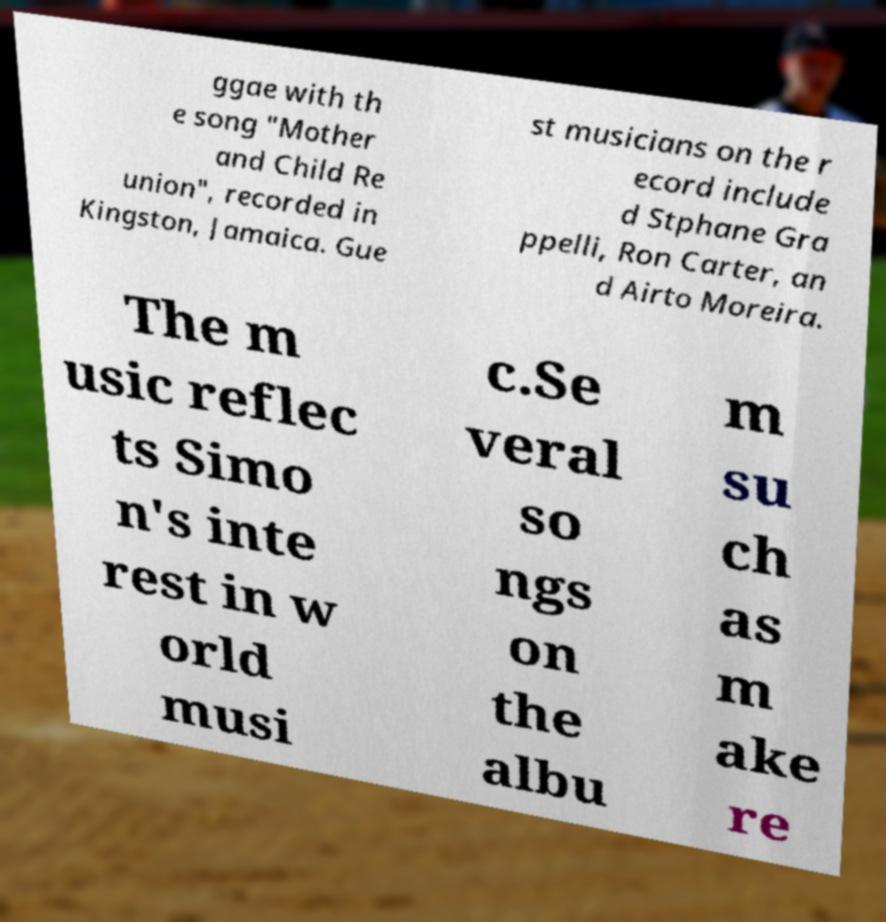Please identify and transcribe the text found in this image. ggae with th e song "Mother and Child Re union", recorded in Kingston, Jamaica. Gue st musicians on the r ecord include d Stphane Gra ppelli, Ron Carter, an d Airto Moreira. The m usic reflec ts Simo n's inte rest in w orld musi c.Se veral so ngs on the albu m su ch as m ake re 